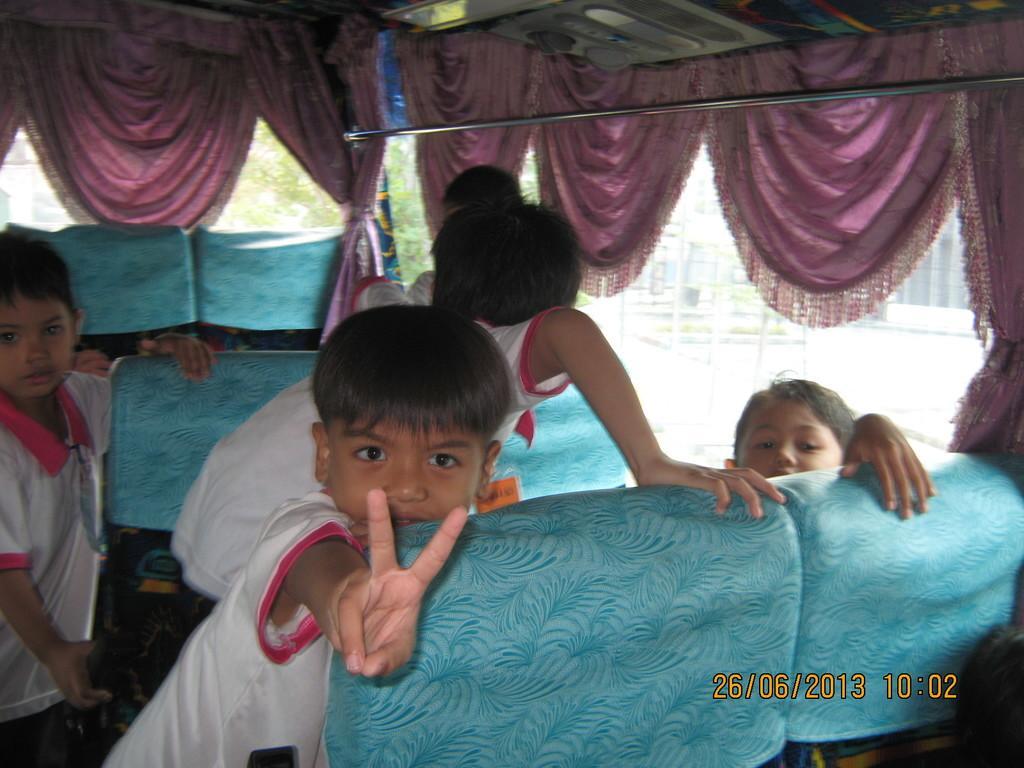Please provide a concise description of this image. This is inside view of a bus. There are seats and many children. Also there are curtains and a steel rod. 